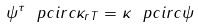<formula> <loc_0><loc_0><loc_500><loc_500>\psi ^ { \tau } \ p c i r c \kappa _ { r T } = \kappa \ p c i r c \psi</formula> 